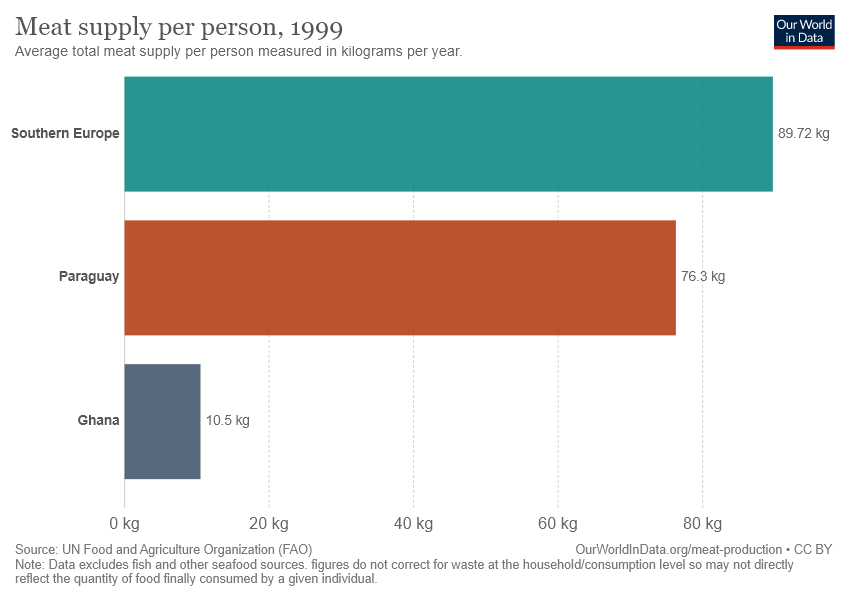What could be the reasons behind the differences in meat supply between these regions? The disparities in meat supply between these regions may be attributed to various factors including economic status, dietary preferences, agricultural practices, availability of land for livestock, and cultural influences. For instance, higher income countries often have higher meat consumption rates, while countries with limited land for animal husbandry or those with predominantly plant-based diets might consume less meat. 